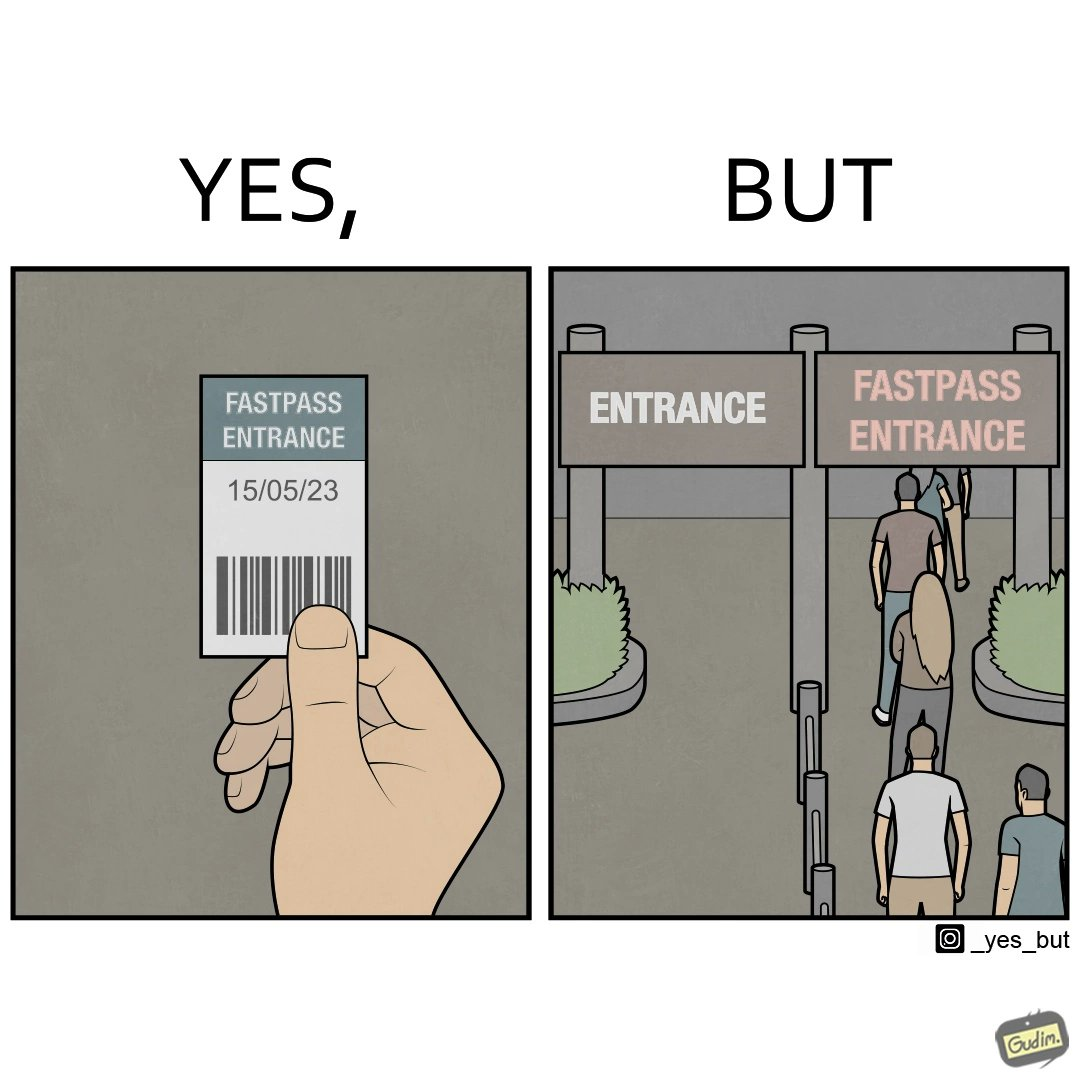Describe what you see in this image. The image is ironic, because fast pass entrance was meant for people to pass the gate fast but as more no. of people bought the pass due to which the queue has become longer and it becomes slow and time consuming 